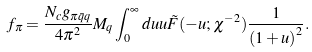<formula> <loc_0><loc_0><loc_500><loc_500>f _ { \pi } = \frac { N _ { c } g _ { \pi \bar { q } q } } { 4 \pi ^ { 2 } } M _ { q } \int _ { 0 } ^ { \infty } d u u \tilde { F } ( - u ; \chi ^ { - 2 } ) \frac { 1 } { \left ( 1 + u \right ) ^ { 2 } } .</formula> 